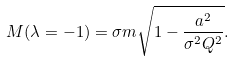Convert formula to latex. <formula><loc_0><loc_0><loc_500><loc_500>M ( \lambda = - 1 ) = \sigma m \sqrt { 1 - \frac { a ^ { 2 } } { \sigma ^ { 2 } Q ^ { 2 } } } .</formula> 